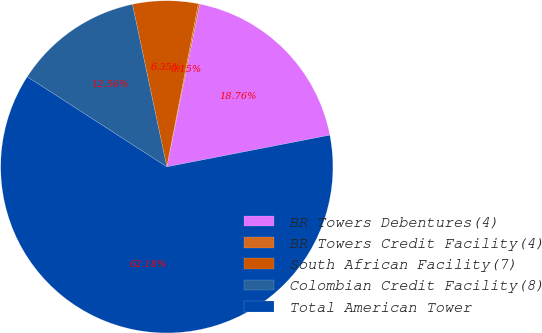Convert chart. <chart><loc_0><loc_0><loc_500><loc_500><pie_chart><fcel>BR Towers Debentures(4)<fcel>BR Towers Credit Facility(4)<fcel>South African Facility(7)<fcel>Colombian Credit Facility(8)<fcel>Total American Tower<nl><fcel>18.76%<fcel>0.15%<fcel>6.35%<fcel>12.56%<fcel>62.18%<nl></chart> 